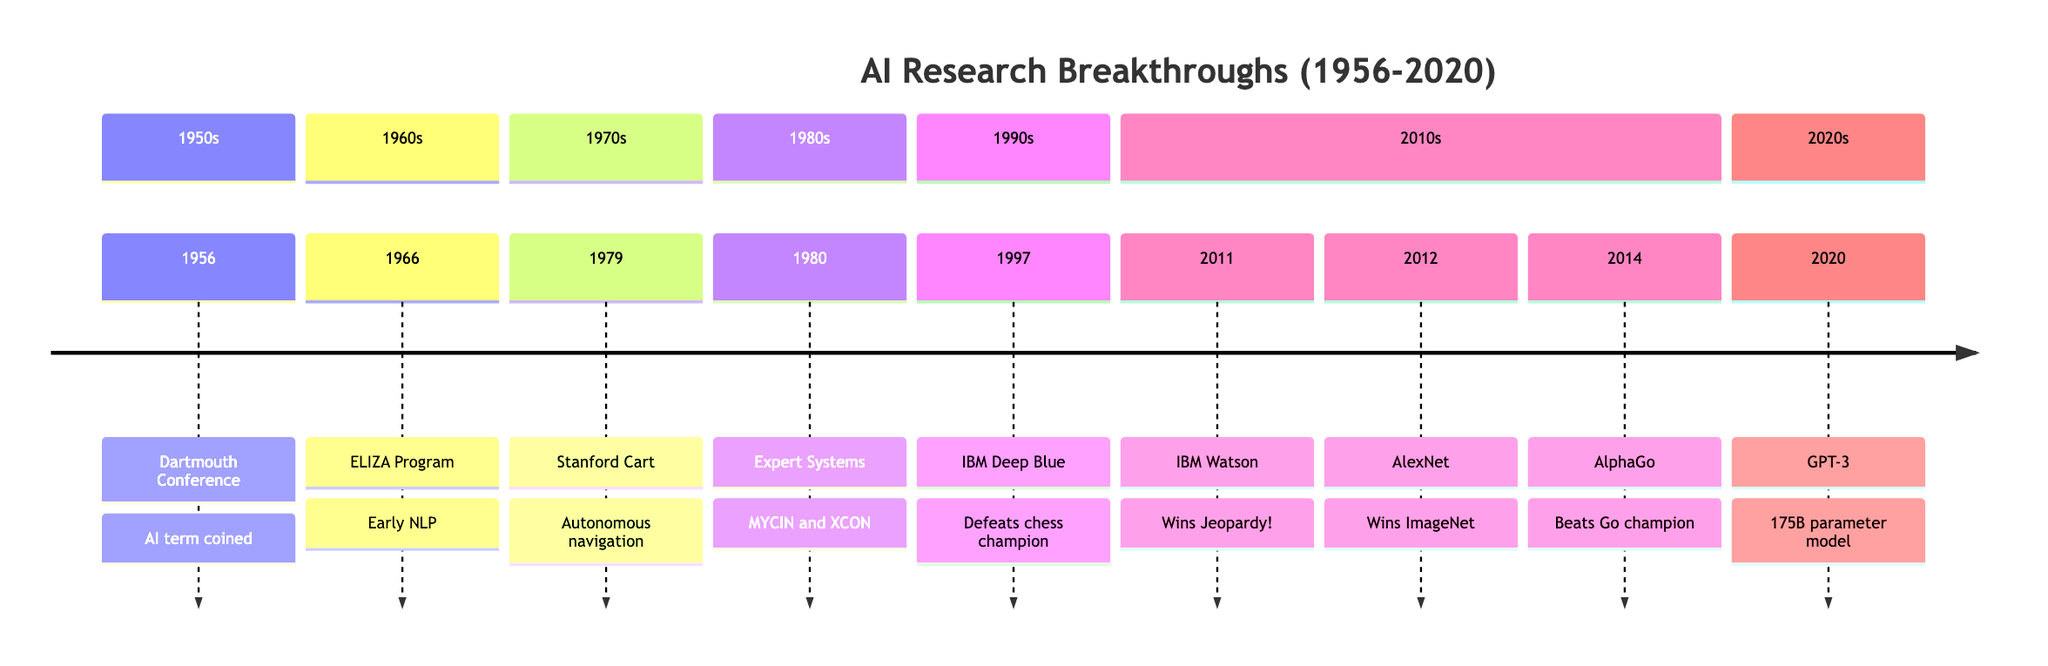What year did the Dartmouth Conference take place? The Dartmouth Conference is marked in the timeline at the year 1956 as the starting point for the field of artificial intelligence.
Answer: 1956 What event occurred in 1997? In the timeline, 1997 is associated with the event "IBM Deep Blue," which is listed under that year as a significant breakthrough.
Answer: IBM Deep Blue How many significant breakthroughs are listed in the timeline? By counting the events outlined in the timeline, we find there are a total of 8 significant breakthroughs recorded from 1956 to 2020.
Answer: 8 What technological advancement did IBM Watson achieve in 2011? Looking at the timeline for the year 2011, it states that IBM Watson won Jeopardy!, showcasing its capabilities in natural language processing.
Answer: Won Jeopardy! Which event directly followed the development of AlexNet? The timeline indicates that AlexNet's achievement in 2012 was followed by AlphaGo's event in 2014, thus establishing a direct chronological relationship.
Answer: AlphaGo Compare the years when IBM Deep Blue and GPT-3 were released. What is the difference in years? From the timeline, IBM Deep Blue was released in 1997 and GPT-3 in 2020. We subtract the earlier year from the later one to find the difference.
Answer: 23 What was the significance of the Stanford Cart in AI history? The description for the Stanford Cart in 1979 states that it was an early demonstration of computer vision and robotics by successfully navigating a room autonomously.
Answer: Autonomous navigation Which section of the timeline includes the most events? By reviewing the sections in the timeline, the 2010s section contains the most events listed, including IBM Watson, AlexNet, and AlphaGo, totaling three events.
Answer: 2010s What breakthrough in AI occurred in 1980? The timeline specifies that the breakthrough in 1980 was the development of Expert Systems, highlighting significant progress in mimicking human expertise.
Answer: Expert Systems 